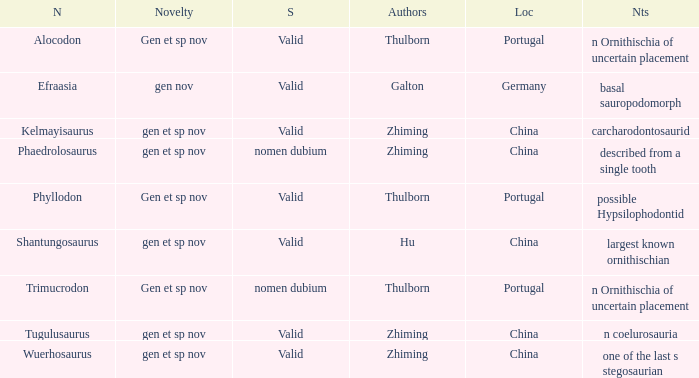What are the Notes of the dinosaur, whose Status is nomen dubium, and whose Location is China? Described from a single tooth. Can you parse all the data within this table? {'header': ['N', 'Novelty', 'S', 'Authors', 'Loc', 'Nts'], 'rows': [['Alocodon', 'Gen et sp nov', 'Valid', 'Thulborn', 'Portugal', 'n Ornithischia of uncertain placement'], ['Efraasia', 'gen nov', 'Valid', 'Galton', 'Germany', 'basal sauropodomorph'], ['Kelmayisaurus', 'gen et sp nov', 'Valid', 'Zhiming', 'China', 'carcharodontosaurid'], ['Phaedrolosaurus', 'gen et sp nov', 'nomen dubium', 'Zhiming', 'China', 'described from a single tooth'], ['Phyllodon', 'Gen et sp nov', 'Valid', 'Thulborn', 'Portugal', 'possible Hypsilophodontid'], ['Shantungosaurus', 'gen et sp nov', 'Valid', 'Hu', 'China', 'largest known ornithischian'], ['Trimucrodon', 'Gen et sp nov', 'nomen dubium', 'Thulborn', 'Portugal', 'n Ornithischia of uncertain placement'], ['Tugulusaurus', 'gen et sp nov', 'Valid', 'Zhiming', 'China', 'n coelurosauria'], ['Wuerhosaurus', 'gen et sp nov', 'Valid', 'Zhiming', 'China', 'one of the last s stegosaurian']]} 